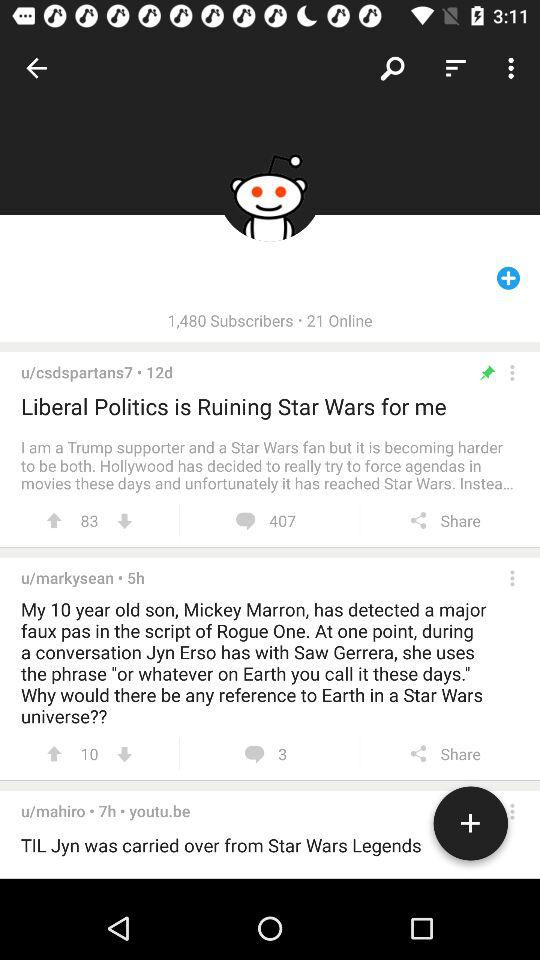What is the number of comments on the "Liberal Politics" topic? The number of comments is 407. 